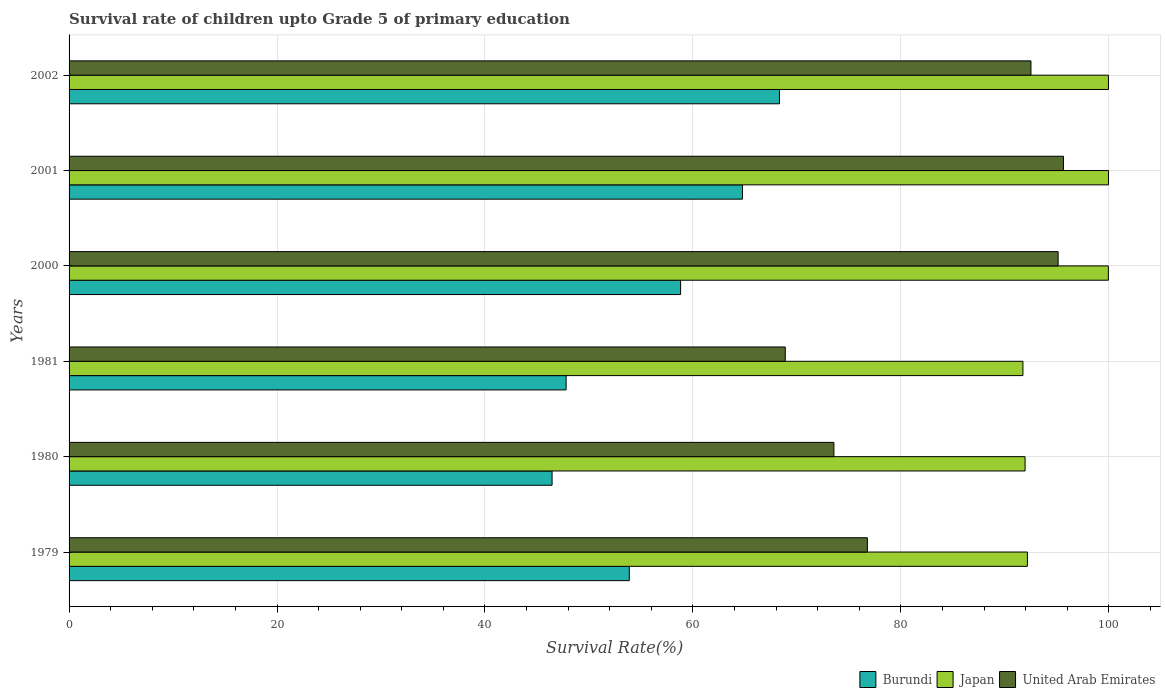How many different coloured bars are there?
Provide a short and direct response. 3. How many groups of bars are there?
Keep it short and to the point. 6. Are the number of bars per tick equal to the number of legend labels?
Make the answer very short. Yes. Are the number of bars on each tick of the Y-axis equal?
Keep it short and to the point. Yes. How many bars are there on the 6th tick from the top?
Make the answer very short. 3. What is the label of the 3rd group of bars from the top?
Provide a succinct answer. 2000. In how many cases, is the number of bars for a given year not equal to the number of legend labels?
Give a very brief answer. 0. What is the survival rate of children in Japan in 1980?
Provide a succinct answer. 91.94. Across all years, what is the maximum survival rate of children in Burundi?
Provide a succinct answer. 68.32. Across all years, what is the minimum survival rate of children in Burundi?
Ensure brevity in your answer.  46.45. In which year was the survival rate of children in United Arab Emirates maximum?
Offer a very short reply. 2001. In which year was the survival rate of children in Burundi minimum?
Ensure brevity in your answer.  1980. What is the total survival rate of children in Burundi in the graph?
Provide a short and direct response. 340.03. What is the difference between the survival rate of children in Burundi in 1981 and that in 2000?
Offer a very short reply. -11.01. What is the difference between the survival rate of children in United Arab Emirates in 1980 and the survival rate of children in Burundi in 2001?
Your answer should be compact. 8.8. What is the average survival rate of children in Burundi per year?
Provide a succinct answer. 56.67. In the year 2000, what is the difference between the survival rate of children in Japan and survival rate of children in United Arab Emirates?
Give a very brief answer. 4.83. In how many years, is the survival rate of children in Japan greater than 8 %?
Give a very brief answer. 6. What is the ratio of the survival rate of children in Japan in 1981 to that in 2001?
Provide a short and direct response. 0.92. Is the survival rate of children in Japan in 1980 less than that in 2002?
Offer a terse response. Yes. What is the difference between the highest and the second highest survival rate of children in Japan?
Provide a succinct answer. 0.01. What is the difference between the highest and the lowest survival rate of children in United Arab Emirates?
Your answer should be very brief. 26.75. In how many years, is the survival rate of children in Japan greater than the average survival rate of children in Japan taken over all years?
Provide a succinct answer. 3. What does the 1st bar from the top in 1981 represents?
Ensure brevity in your answer.  United Arab Emirates. What does the 2nd bar from the bottom in 1981 represents?
Ensure brevity in your answer.  Japan. How many bars are there?
Offer a very short reply. 18. Are the values on the major ticks of X-axis written in scientific E-notation?
Make the answer very short. No. Does the graph contain any zero values?
Offer a very short reply. No. Does the graph contain grids?
Offer a terse response. Yes. How are the legend labels stacked?
Keep it short and to the point. Horizontal. What is the title of the graph?
Offer a very short reply. Survival rate of children upto Grade 5 of primary education. What is the label or title of the X-axis?
Provide a short and direct response. Survival Rate(%). What is the label or title of the Y-axis?
Your answer should be very brief. Years. What is the Survival Rate(%) of Burundi in 1979?
Your answer should be compact. 53.88. What is the Survival Rate(%) of Japan in 1979?
Provide a short and direct response. 92.17. What is the Survival Rate(%) in United Arab Emirates in 1979?
Your answer should be compact. 76.78. What is the Survival Rate(%) of Burundi in 1980?
Offer a very short reply. 46.45. What is the Survival Rate(%) in Japan in 1980?
Offer a terse response. 91.94. What is the Survival Rate(%) in United Arab Emirates in 1980?
Your answer should be very brief. 73.56. What is the Survival Rate(%) of Burundi in 1981?
Make the answer very short. 47.8. What is the Survival Rate(%) of Japan in 1981?
Offer a very short reply. 91.73. What is the Survival Rate(%) of United Arab Emirates in 1981?
Provide a succinct answer. 68.88. What is the Survival Rate(%) of Burundi in 2000?
Keep it short and to the point. 58.81. What is the Survival Rate(%) in Japan in 2000?
Provide a short and direct response. 99.95. What is the Survival Rate(%) of United Arab Emirates in 2000?
Offer a very short reply. 95.12. What is the Survival Rate(%) in Burundi in 2001?
Give a very brief answer. 64.76. What is the Survival Rate(%) of Japan in 2001?
Offer a very short reply. 99.97. What is the Survival Rate(%) in United Arab Emirates in 2001?
Your response must be concise. 95.63. What is the Survival Rate(%) of Burundi in 2002?
Ensure brevity in your answer.  68.32. What is the Survival Rate(%) of Japan in 2002?
Your answer should be compact. 99.96. What is the Survival Rate(%) in United Arab Emirates in 2002?
Make the answer very short. 92.51. Across all years, what is the maximum Survival Rate(%) of Burundi?
Your response must be concise. 68.32. Across all years, what is the maximum Survival Rate(%) in Japan?
Your answer should be compact. 99.97. Across all years, what is the maximum Survival Rate(%) of United Arab Emirates?
Offer a very short reply. 95.63. Across all years, what is the minimum Survival Rate(%) of Burundi?
Provide a short and direct response. 46.45. Across all years, what is the minimum Survival Rate(%) of Japan?
Make the answer very short. 91.73. Across all years, what is the minimum Survival Rate(%) in United Arab Emirates?
Offer a very short reply. 68.88. What is the total Survival Rate(%) in Burundi in the graph?
Keep it short and to the point. 340.03. What is the total Survival Rate(%) in Japan in the graph?
Offer a terse response. 575.72. What is the total Survival Rate(%) of United Arab Emirates in the graph?
Offer a terse response. 502.47. What is the difference between the Survival Rate(%) of Burundi in 1979 and that in 1980?
Make the answer very short. 7.43. What is the difference between the Survival Rate(%) of Japan in 1979 and that in 1980?
Offer a very short reply. 0.22. What is the difference between the Survival Rate(%) of United Arab Emirates in 1979 and that in 1980?
Ensure brevity in your answer.  3.22. What is the difference between the Survival Rate(%) in Burundi in 1979 and that in 1981?
Make the answer very short. 6.08. What is the difference between the Survival Rate(%) of Japan in 1979 and that in 1981?
Offer a terse response. 0.43. What is the difference between the Survival Rate(%) of United Arab Emirates in 1979 and that in 1981?
Your answer should be very brief. 7.9. What is the difference between the Survival Rate(%) in Burundi in 1979 and that in 2000?
Provide a short and direct response. -4.93. What is the difference between the Survival Rate(%) in Japan in 1979 and that in 2000?
Offer a terse response. -7.79. What is the difference between the Survival Rate(%) in United Arab Emirates in 1979 and that in 2000?
Make the answer very short. -18.34. What is the difference between the Survival Rate(%) in Burundi in 1979 and that in 2001?
Provide a succinct answer. -10.88. What is the difference between the Survival Rate(%) of Japan in 1979 and that in 2001?
Give a very brief answer. -7.8. What is the difference between the Survival Rate(%) of United Arab Emirates in 1979 and that in 2001?
Offer a terse response. -18.86. What is the difference between the Survival Rate(%) of Burundi in 1979 and that in 2002?
Offer a very short reply. -14.45. What is the difference between the Survival Rate(%) of Japan in 1979 and that in 2002?
Provide a succinct answer. -7.79. What is the difference between the Survival Rate(%) of United Arab Emirates in 1979 and that in 2002?
Your answer should be very brief. -15.73. What is the difference between the Survival Rate(%) in Burundi in 1980 and that in 1981?
Make the answer very short. -1.35. What is the difference between the Survival Rate(%) in Japan in 1980 and that in 1981?
Your answer should be compact. 0.21. What is the difference between the Survival Rate(%) in United Arab Emirates in 1980 and that in 1981?
Offer a very short reply. 4.68. What is the difference between the Survival Rate(%) in Burundi in 1980 and that in 2000?
Give a very brief answer. -12.36. What is the difference between the Survival Rate(%) in Japan in 1980 and that in 2000?
Provide a short and direct response. -8.01. What is the difference between the Survival Rate(%) of United Arab Emirates in 1980 and that in 2000?
Make the answer very short. -21.56. What is the difference between the Survival Rate(%) of Burundi in 1980 and that in 2001?
Your answer should be compact. -18.31. What is the difference between the Survival Rate(%) in Japan in 1980 and that in 2001?
Make the answer very short. -8.03. What is the difference between the Survival Rate(%) of United Arab Emirates in 1980 and that in 2001?
Your answer should be very brief. -22.08. What is the difference between the Survival Rate(%) of Burundi in 1980 and that in 2002?
Your response must be concise. -21.87. What is the difference between the Survival Rate(%) in Japan in 1980 and that in 2002?
Offer a very short reply. -8.02. What is the difference between the Survival Rate(%) of United Arab Emirates in 1980 and that in 2002?
Offer a very short reply. -18.95. What is the difference between the Survival Rate(%) of Burundi in 1981 and that in 2000?
Your answer should be compact. -11.01. What is the difference between the Survival Rate(%) in Japan in 1981 and that in 2000?
Provide a succinct answer. -8.22. What is the difference between the Survival Rate(%) in United Arab Emirates in 1981 and that in 2000?
Your answer should be very brief. -26.24. What is the difference between the Survival Rate(%) of Burundi in 1981 and that in 2001?
Offer a terse response. -16.96. What is the difference between the Survival Rate(%) in Japan in 1981 and that in 2001?
Offer a terse response. -8.23. What is the difference between the Survival Rate(%) of United Arab Emirates in 1981 and that in 2001?
Ensure brevity in your answer.  -26.75. What is the difference between the Survival Rate(%) in Burundi in 1981 and that in 2002?
Your response must be concise. -20.52. What is the difference between the Survival Rate(%) in Japan in 1981 and that in 2002?
Offer a very short reply. -8.23. What is the difference between the Survival Rate(%) of United Arab Emirates in 1981 and that in 2002?
Provide a short and direct response. -23.63. What is the difference between the Survival Rate(%) of Burundi in 2000 and that in 2001?
Provide a succinct answer. -5.95. What is the difference between the Survival Rate(%) of Japan in 2000 and that in 2001?
Provide a short and direct response. -0.02. What is the difference between the Survival Rate(%) of United Arab Emirates in 2000 and that in 2001?
Your response must be concise. -0.51. What is the difference between the Survival Rate(%) of Burundi in 2000 and that in 2002?
Provide a succinct answer. -9.51. What is the difference between the Survival Rate(%) in Japan in 2000 and that in 2002?
Provide a short and direct response. -0.01. What is the difference between the Survival Rate(%) in United Arab Emirates in 2000 and that in 2002?
Your response must be concise. 2.61. What is the difference between the Survival Rate(%) in Burundi in 2001 and that in 2002?
Provide a succinct answer. -3.56. What is the difference between the Survival Rate(%) in Japan in 2001 and that in 2002?
Provide a short and direct response. 0.01. What is the difference between the Survival Rate(%) of United Arab Emirates in 2001 and that in 2002?
Make the answer very short. 3.13. What is the difference between the Survival Rate(%) of Burundi in 1979 and the Survival Rate(%) of Japan in 1980?
Offer a very short reply. -38.06. What is the difference between the Survival Rate(%) of Burundi in 1979 and the Survival Rate(%) of United Arab Emirates in 1980?
Your response must be concise. -19.68. What is the difference between the Survival Rate(%) of Japan in 1979 and the Survival Rate(%) of United Arab Emirates in 1980?
Provide a succinct answer. 18.61. What is the difference between the Survival Rate(%) in Burundi in 1979 and the Survival Rate(%) in Japan in 1981?
Your answer should be compact. -37.86. What is the difference between the Survival Rate(%) of Burundi in 1979 and the Survival Rate(%) of United Arab Emirates in 1981?
Keep it short and to the point. -15. What is the difference between the Survival Rate(%) in Japan in 1979 and the Survival Rate(%) in United Arab Emirates in 1981?
Your response must be concise. 23.29. What is the difference between the Survival Rate(%) in Burundi in 1979 and the Survival Rate(%) in Japan in 2000?
Your answer should be compact. -46.07. What is the difference between the Survival Rate(%) of Burundi in 1979 and the Survival Rate(%) of United Arab Emirates in 2000?
Make the answer very short. -41.24. What is the difference between the Survival Rate(%) in Japan in 1979 and the Survival Rate(%) in United Arab Emirates in 2000?
Provide a short and direct response. -2.95. What is the difference between the Survival Rate(%) in Burundi in 1979 and the Survival Rate(%) in Japan in 2001?
Offer a terse response. -46.09. What is the difference between the Survival Rate(%) in Burundi in 1979 and the Survival Rate(%) in United Arab Emirates in 2001?
Make the answer very short. -41.75. What is the difference between the Survival Rate(%) in Japan in 1979 and the Survival Rate(%) in United Arab Emirates in 2001?
Make the answer very short. -3.47. What is the difference between the Survival Rate(%) of Burundi in 1979 and the Survival Rate(%) of Japan in 2002?
Make the answer very short. -46.08. What is the difference between the Survival Rate(%) of Burundi in 1979 and the Survival Rate(%) of United Arab Emirates in 2002?
Make the answer very short. -38.63. What is the difference between the Survival Rate(%) of Japan in 1979 and the Survival Rate(%) of United Arab Emirates in 2002?
Your response must be concise. -0.34. What is the difference between the Survival Rate(%) in Burundi in 1980 and the Survival Rate(%) in Japan in 1981?
Your answer should be very brief. -45.28. What is the difference between the Survival Rate(%) of Burundi in 1980 and the Survival Rate(%) of United Arab Emirates in 1981?
Make the answer very short. -22.43. What is the difference between the Survival Rate(%) of Japan in 1980 and the Survival Rate(%) of United Arab Emirates in 1981?
Offer a very short reply. 23.06. What is the difference between the Survival Rate(%) of Burundi in 1980 and the Survival Rate(%) of Japan in 2000?
Keep it short and to the point. -53.5. What is the difference between the Survival Rate(%) of Burundi in 1980 and the Survival Rate(%) of United Arab Emirates in 2000?
Your response must be concise. -48.67. What is the difference between the Survival Rate(%) of Japan in 1980 and the Survival Rate(%) of United Arab Emirates in 2000?
Provide a short and direct response. -3.18. What is the difference between the Survival Rate(%) in Burundi in 1980 and the Survival Rate(%) in Japan in 2001?
Your response must be concise. -53.51. What is the difference between the Survival Rate(%) of Burundi in 1980 and the Survival Rate(%) of United Arab Emirates in 2001?
Offer a very short reply. -49.18. What is the difference between the Survival Rate(%) in Japan in 1980 and the Survival Rate(%) in United Arab Emirates in 2001?
Provide a succinct answer. -3.69. What is the difference between the Survival Rate(%) in Burundi in 1980 and the Survival Rate(%) in Japan in 2002?
Ensure brevity in your answer.  -53.51. What is the difference between the Survival Rate(%) of Burundi in 1980 and the Survival Rate(%) of United Arab Emirates in 2002?
Provide a short and direct response. -46.05. What is the difference between the Survival Rate(%) in Japan in 1980 and the Survival Rate(%) in United Arab Emirates in 2002?
Your answer should be compact. -0.56. What is the difference between the Survival Rate(%) of Burundi in 1981 and the Survival Rate(%) of Japan in 2000?
Offer a very short reply. -52.15. What is the difference between the Survival Rate(%) in Burundi in 1981 and the Survival Rate(%) in United Arab Emirates in 2000?
Your answer should be compact. -47.32. What is the difference between the Survival Rate(%) of Japan in 1981 and the Survival Rate(%) of United Arab Emirates in 2000?
Provide a short and direct response. -3.39. What is the difference between the Survival Rate(%) of Burundi in 1981 and the Survival Rate(%) of Japan in 2001?
Give a very brief answer. -52.16. What is the difference between the Survival Rate(%) in Burundi in 1981 and the Survival Rate(%) in United Arab Emirates in 2001?
Provide a short and direct response. -47.83. What is the difference between the Survival Rate(%) of Japan in 1981 and the Survival Rate(%) of United Arab Emirates in 2001?
Offer a terse response. -3.9. What is the difference between the Survival Rate(%) of Burundi in 1981 and the Survival Rate(%) of Japan in 2002?
Keep it short and to the point. -52.16. What is the difference between the Survival Rate(%) in Burundi in 1981 and the Survival Rate(%) in United Arab Emirates in 2002?
Offer a terse response. -44.7. What is the difference between the Survival Rate(%) of Japan in 1981 and the Survival Rate(%) of United Arab Emirates in 2002?
Offer a very short reply. -0.77. What is the difference between the Survival Rate(%) of Burundi in 2000 and the Survival Rate(%) of Japan in 2001?
Keep it short and to the point. -41.16. What is the difference between the Survival Rate(%) of Burundi in 2000 and the Survival Rate(%) of United Arab Emirates in 2001?
Ensure brevity in your answer.  -36.82. What is the difference between the Survival Rate(%) in Japan in 2000 and the Survival Rate(%) in United Arab Emirates in 2001?
Make the answer very short. 4.32. What is the difference between the Survival Rate(%) in Burundi in 2000 and the Survival Rate(%) in Japan in 2002?
Provide a short and direct response. -41.15. What is the difference between the Survival Rate(%) of Burundi in 2000 and the Survival Rate(%) of United Arab Emirates in 2002?
Give a very brief answer. -33.69. What is the difference between the Survival Rate(%) of Japan in 2000 and the Survival Rate(%) of United Arab Emirates in 2002?
Offer a terse response. 7.45. What is the difference between the Survival Rate(%) of Burundi in 2001 and the Survival Rate(%) of Japan in 2002?
Provide a succinct answer. -35.2. What is the difference between the Survival Rate(%) of Burundi in 2001 and the Survival Rate(%) of United Arab Emirates in 2002?
Your answer should be compact. -27.75. What is the difference between the Survival Rate(%) in Japan in 2001 and the Survival Rate(%) in United Arab Emirates in 2002?
Your answer should be very brief. 7.46. What is the average Survival Rate(%) in Burundi per year?
Offer a terse response. 56.67. What is the average Survival Rate(%) in Japan per year?
Provide a short and direct response. 95.95. What is the average Survival Rate(%) in United Arab Emirates per year?
Provide a succinct answer. 83.75. In the year 1979, what is the difference between the Survival Rate(%) of Burundi and Survival Rate(%) of Japan?
Offer a very short reply. -38.29. In the year 1979, what is the difference between the Survival Rate(%) in Burundi and Survival Rate(%) in United Arab Emirates?
Offer a terse response. -22.9. In the year 1979, what is the difference between the Survival Rate(%) of Japan and Survival Rate(%) of United Arab Emirates?
Provide a short and direct response. 15.39. In the year 1980, what is the difference between the Survival Rate(%) in Burundi and Survival Rate(%) in Japan?
Make the answer very short. -45.49. In the year 1980, what is the difference between the Survival Rate(%) of Burundi and Survival Rate(%) of United Arab Emirates?
Provide a short and direct response. -27.1. In the year 1980, what is the difference between the Survival Rate(%) in Japan and Survival Rate(%) in United Arab Emirates?
Provide a succinct answer. 18.39. In the year 1981, what is the difference between the Survival Rate(%) of Burundi and Survival Rate(%) of Japan?
Ensure brevity in your answer.  -43.93. In the year 1981, what is the difference between the Survival Rate(%) of Burundi and Survival Rate(%) of United Arab Emirates?
Provide a short and direct response. -21.08. In the year 1981, what is the difference between the Survival Rate(%) in Japan and Survival Rate(%) in United Arab Emirates?
Your answer should be compact. 22.86. In the year 2000, what is the difference between the Survival Rate(%) of Burundi and Survival Rate(%) of Japan?
Give a very brief answer. -41.14. In the year 2000, what is the difference between the Survival Rate(%) of Burundi and Survival Rate(%) of United Arab Emirates?
Offer a terse response. -36.31. In the year 2000, what is the difference between the Survival Rate(%) in Japan and Survival Rate(%) in United Arab Emirates?
Keep it short and to the point. 4.83. In the year 2001, what is the difference between the Survival Rate(%) in Burundi and Survival Rate(%) in Japan?
Your answer should be compact. -35.21. In the year 2001, what is the difference between the Survival Rate(%) in Burundi and Survival Rate(%) in United Arab Emirates?
Provide a succinct answer. -30.87. In the year 2001, what is the difference between the Survival Rate(%) of Japan and Survival Rate(%) of United Arab Emirates?
Give a very brief answer. 4.33. In the year 2002, what is the difference between the Survival Rate(%) of Burundi and Survival Rate(%) of Japan?
Your answer should be compact. -31.64. In the year 2002, what is the difference between the Survival Rate(%) of Burundi and Survival Rate(%) of United Arab Emirates?
Make the answer very short. -24.18. In the year 2002, what is the difference between the Survival Rate(%) of Japan and Survival Rate(%) of United Arab Emirates?
Your answer should be very brief. 7.45. What is the ratio of the Survival Rate(%) of Burundi in 1979 to that in 1980?
Offer a very short reply. 1.16. What is the ratio of the Survival Rate(%) in Japan in 1979 to that in 1980?
Ensure brevity in your answer.  1. What is the ratio of the Survival Rate(%) of United Arab Emirates in 1979 to that in 1980?
Offer a very short reply. 1.04. What is the ratio of the Survival Rate(%) in Burundi in 1979 to that in 1981?
Make the answer very short. 1.13. What is the ratio of the Survival Rate(%) in United Arab Emirates in 1979 to that in 1981?
Your answer should be very brief. 1.11. What is the ratio of the Survival Rate(%) of Burundi in 1979 to that in 2000?
Offer a very short reply. 0.92. What is the ratio of the Survival Rate(%) of Japan in 1979 to that in 2000?
Provide a short and direct response. 0.92. What is the ratio of the Survival Rate(%) in United Arab Emirates in 1979 to that in 2000?
Your response must be concise. 0.81. What is the ratio of the Survival Rate(%) in Burundi in 1979 to that in 2001?
Provide a short and direct response. 0.83. What is the ratio of the Survival Rate(%) of Japan in 1979 to that in 2001?
Your answer should be very brief. 0.92. What is the ratio of the Survival Rate(%) of United Arab Emirates in 1979 to that in 2001?
Offer a very short reply. 0.8. What is the ratio of the Survival Rate(%) in Burundi in 1979 to that in 2002?
Ensure brevity in your answer.  0.79. What is the ratio of the Survival Rate(%) of Japan in 1979 to that in 2002?
Offer a very short reply. 0.92. What is the ratio of the Survival Rate(%) in United Arab Emirates in 1979 to that in 2002?
Make the answer very short. 0.83. What is the ratio of the Survival Rate(%) in Burundi in 1980 to that in 1981?
Provide a short and direct response. 0.97. What is the ratio of the Survival Rate(%) in Japan in 1980 to that in 1981?
Give a very brief answer. 1. What is the ratio of the Survival Rate(%) of United Arab Emirates in 1980 to that in 1981?
Provide a short and direct response. 1.07. What is the ratio of the Survival Rate(%) in Burundi in 1980 to that in 2000?
Ensure brevity in your answer.  0.79. What is the ratio of the Survival Rate(%) in Japan in 1980 to that in 2000?
Your response must be concise. 0.92. What is the ratio of the Survival Rate(%) in United Arab Emirates in 1980 to that in 2000?
Provide a short and direct response. 0.77. What is the ratio of the Survival Rate(%) in Burundi in 1980 to that in 2001?
Provide a short and direct response. 0.72. What is the ratio of the Survival Rate(%) of Japan in 1980 to that in 2001?
Your response must be concise. 0.92. What is the ratio of the Survival Rate(%) in United Arab Emirates in 1980 to that in 2001?
Provide a short and direct response. 0.77. What is the ratio of the Survival Rate(%) in Burundi in 1980 to that in 2002?
Give a very brief answer. 0.68. What is the ratio of the Survival Rate(%) of Japan in 1980 to that in 2002?
Your answer should be compact. 0.92. What is the ratio of the Survival Rate(%) of United Arab Emirates in 1980 to that in 2002?
Make the answer very short. 0.8. What is the ratio of the Survival Rate(%) in Burundi in 1981 to that in 2000?
Provide a short and direct response. 0.81. What is the ratio of the Survival Rate(%) of Japan in 1981 to that in 2000?
Your answer should be compact. 0.92. What is the ratio of the Survival Rate(%) of United Arab Emirates in 1981 to that in 2000?
Provide a succinct answer. 0.72. What is the ratio of the Survival Rate(%) in Burundi in 1981 to that in 2001?
Your answer should be compact. 0.74. What is the ratio of the Survival Rate(%) in Japan in 1981 to that in 2001?
Offer a terse response. 0.92. What is the ratio of the Survival Rate(%) in United Arab Emirates in 1981 to that in 2001?
Your answer should be compact. 0.72. What is the ratio of the Survival Rate(%) of Burundi in 1981 to that in 2002?
Provide a succinct answer. 0.7. What is the ratio of the Survival Rate(%) in Japan in 1981 to that in 2002?
Ensure brevity in your answer.  0.92. What is the ratio of the Survival Rate(%) of United Arab Emirates in 1981 to that in 2002?
Your answer should be compact. 0.74. What is the ratio of the Survival Rate(%) in Burundi in 2000 to that in 2001?
Offer a very short reply. 0.91. What is the ratio of the Survival Rate(%) of Japan in 2000 to that in 2001?
Offer a terse response. 1. What is the ratio of the Survival Rate(%) of United Arab Emirates in 2000 to that in 2001?
Your answer should be compact. 0.99. What is the ratio of the Survival Rate(%) of Burundi in 2000 to that in 2002?
Your answer should be very brief. 0.86. What is the ratio of the Survival Rate(%) in United Arab Emirates in 2000 to that in 2002?
Your answer should be compact. 1.03. What is the ratio of the Survival Rate(%) of Burundi in 2001 to that in 2002?
Ensure brevity in your answer.  0.95. What is the ratio of the Survival Rate(%) of United Arab Emirates in 2001 to that in 2002?
Offer a terse response. 1.03. What is the difference between the highest and the second highest Survival Rate(%) of Burundi?
Provide a succinct answer. 3.56. What is the difference between the highest and the second highest Survival Rate(%) in Japan?
Ensure brevity in your answer.  0.01. What is the difference between the highest and the second highest Survival Rate(%) of United Arab Emirates?
Provide a succinct answer. 0.51. What is the difference between the highest and the lowest Survival Rate(%) of Burundi?
Your answer should be compact. 21.87. What is the difference between the highest and the lowest Survival Rate(%) in Japan?
Your answer should be very brief. 8.23. What is the difference between the highest and the lowest Survival Rate(%) in United Arab Emirates?
Your answer should be compact. 26.75. 